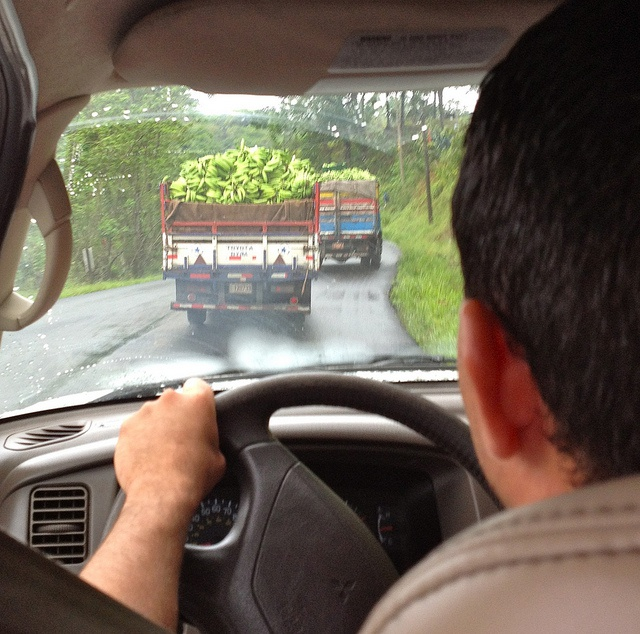Describe the objects in this image and their specific colors. I can see people in gray, black, maroon, salmon, and tan tones, truck in gray, darkgray, and ivory tones, truck in gray and darkgray tones, banana in gray, khaki, olive, lightgreen, and lightyellow tones, and banana in gray, khaki, olive, and lightgreen tones in this image. 